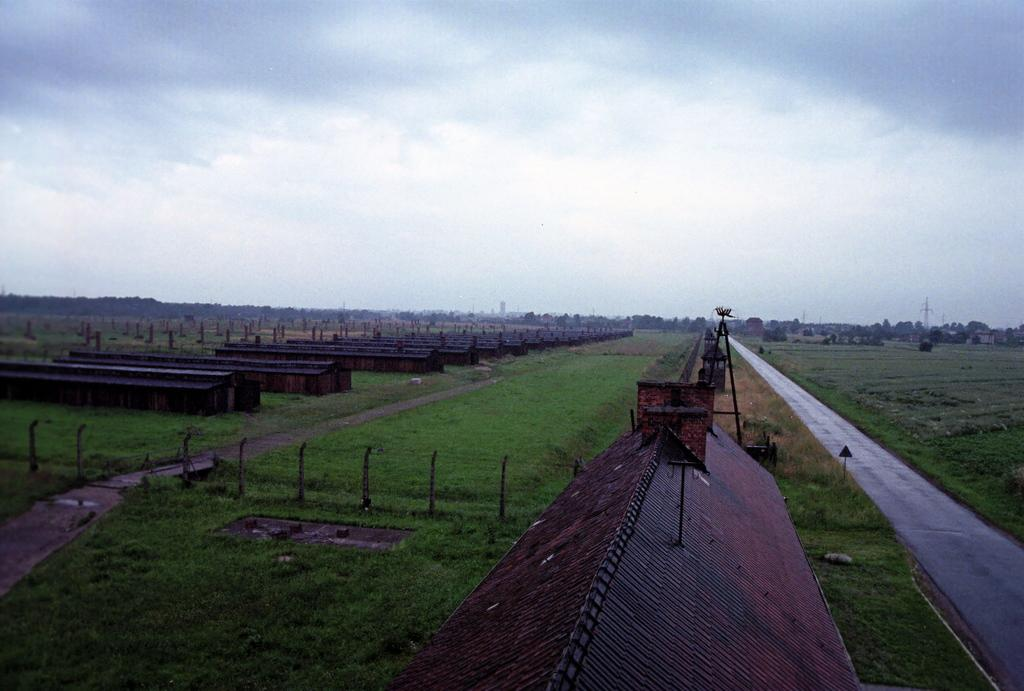What type of structures can be seen in the image? There are houses in the image. What is present around the houses? There is fencing in the image. What can be seen in the background of the image? There are trees and towers in the background of the image. What is the color of the trees? The trees are green in color. What is visible in the sky in the image? The sky is visible in the image, with white and gray colors. What flavor of pollution can be seen in the image? There is no pollution present in the image, so it is not possible to determine its flavor. 